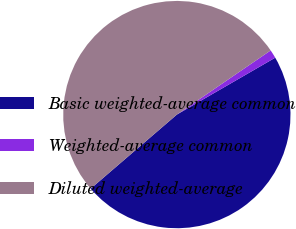Convert chart. <chart><loc_0><loc_0><loc_500><loc_500><pie_chart><fcel>Basic weighted-average common<fcel>Weighted-average common<fcel>Diluted weighted-average<nl><fcel>47.05%<fcel>1.2%<fcel>51.75%<nl></chart> 